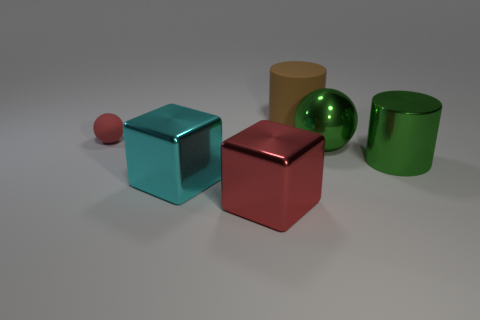Is there any other thing that has the same size as the red matte ball?
Your answer should be very brief. No. There is a large green sphere that is left of the big metal cylinder; what is its material?
Your response must be concise. Metal. Do the matte sphere and the cyan object have the same size?
Ensure brevity in your answer.  No. There is a object that is both in front of the large rubber cylinder and behind the large green shiny sphere; what color is it?
Your response must be concise. Red. What shape is the red object that is the same material as the big cyan thing?
Offer a very short reply. Cube. How many spheres are in front of the small rubber ball and left of the large brown rubber thing?
Your answer should be compact. 0. There is a big cyan metallic cube; are there any red matte balls behind it?
Your response must be concise. Yes. Do the red object that is in front of the tiny ball and the matte thing behind the tiny rubber ball have the same shape?
Make the answer very short. No. How many things are either tiny green matte cylinders or metal objects that are to the left of the brown rubber cylinder?
Offer a very short reply. 2. What number of other objects are the same shape as the red shiny thing?
Provide a short and direct response. 1. 